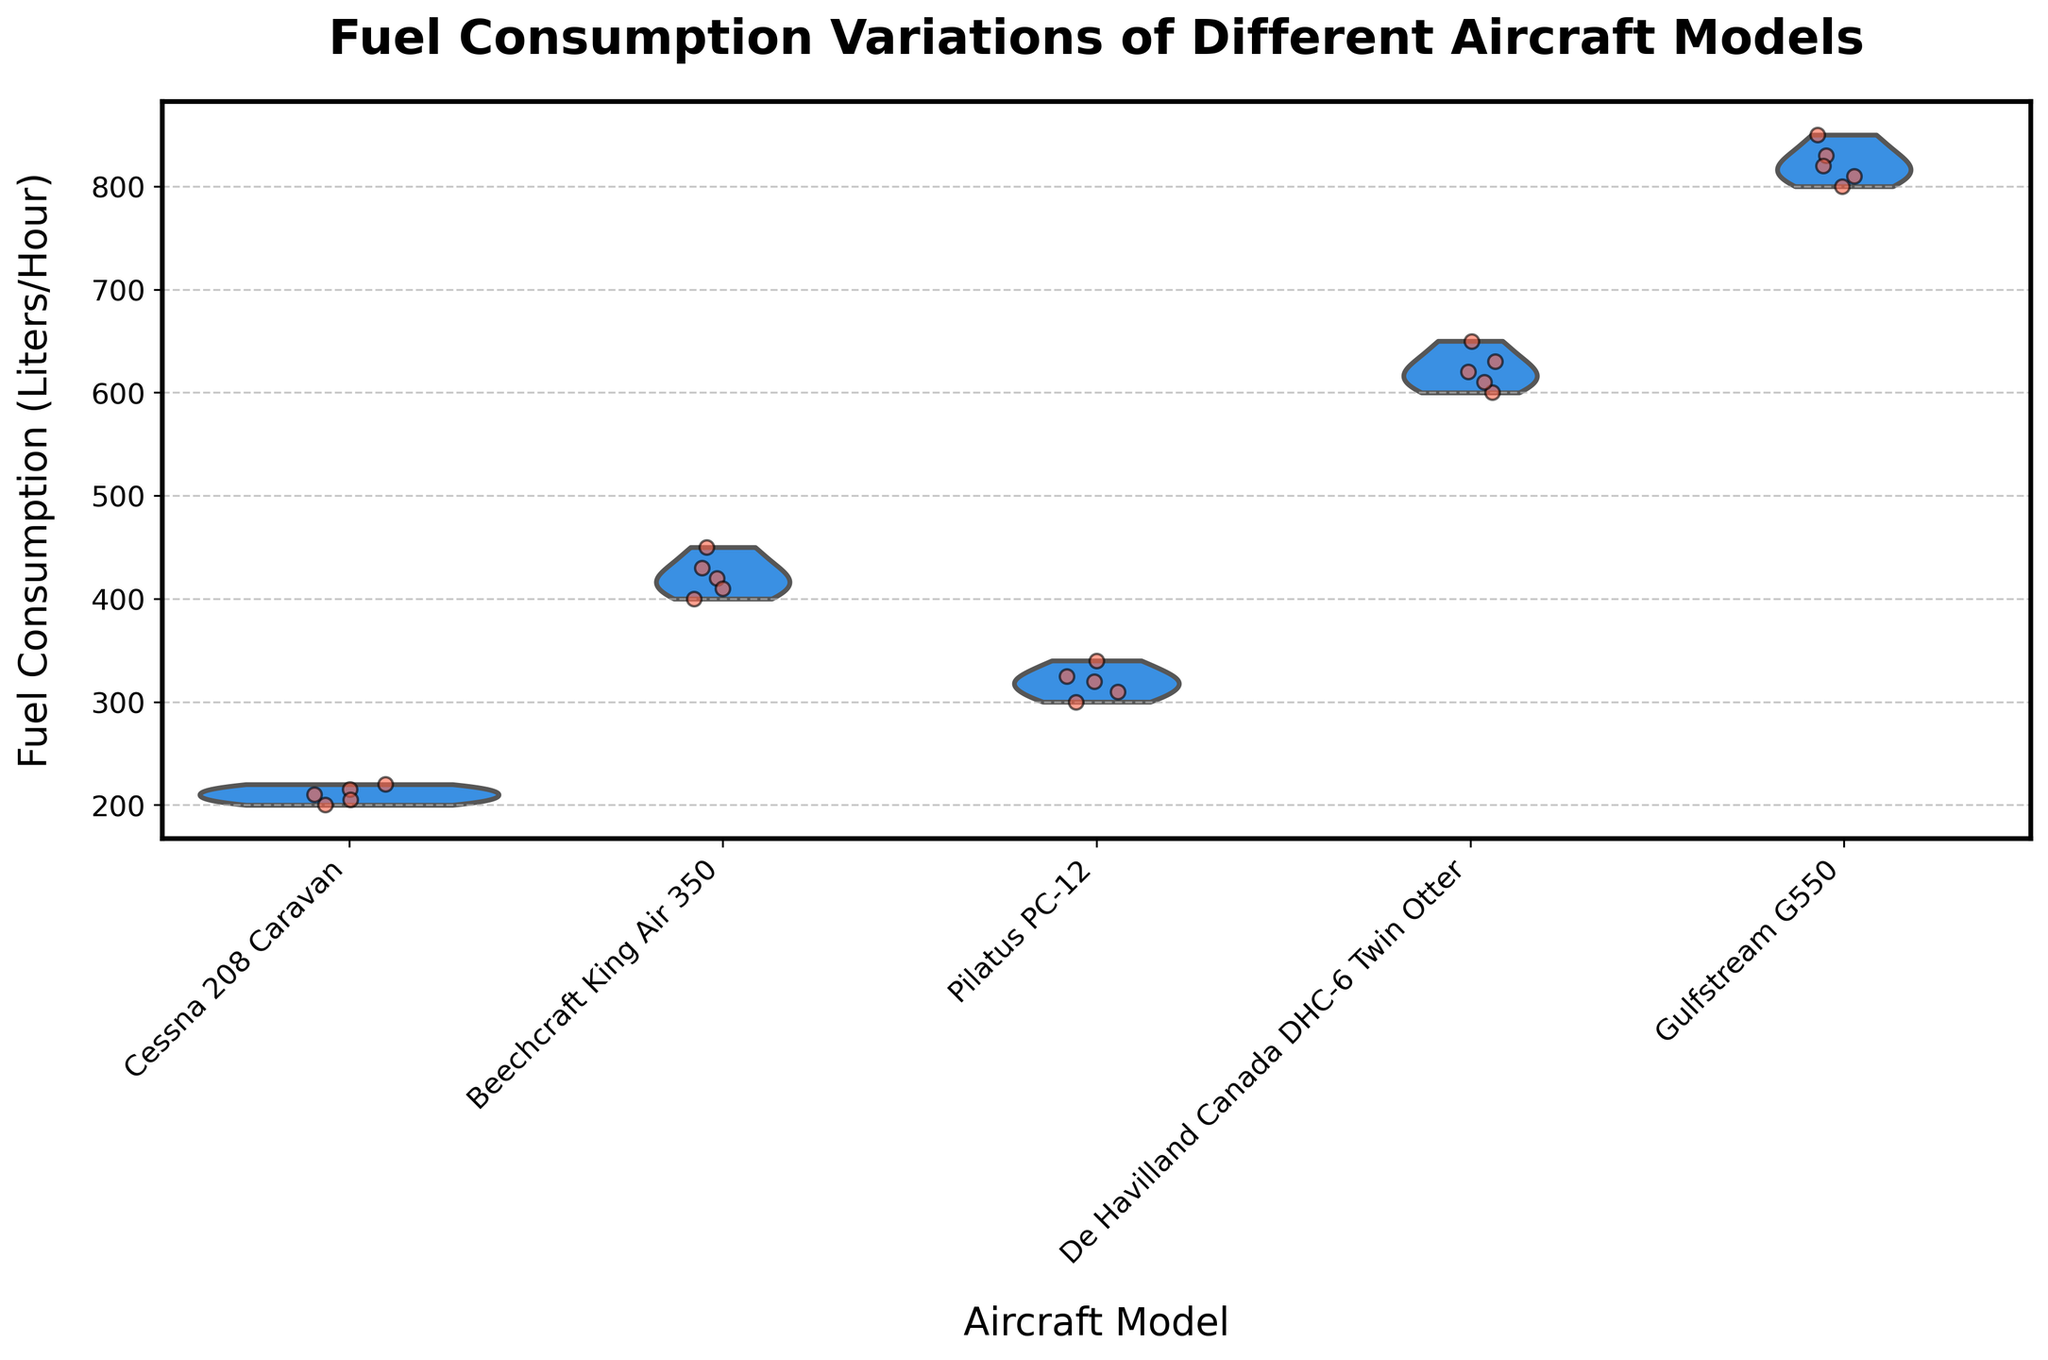What is the title of the plot? The title can be found at the top of the plot, where it is usually prominently displayed. The title reads "Fuel Consumption Variations of Different Aircraft Models."
Answer: Fuel Consumption Variations of Different Aircraft Models Which aircraft model has the highest median fuel consumption? By observing the violin plots, the aircraft model with the highest median line (usually white dot or line) needs to be identified. The Gulfstream G550 shows the highest median fuel consumption.
Answer: Gulfstream G550 What is the range of fuel consumption for the Pilatus PC-12? The range can be assessed by looking at the extent of the violin plot from the lowest to the highest points. For the Pilatus PC-12, this range goes from about 300 to 340 liters per hour.
Answer: 300-340 liters per hour Which aircraft model shows the widest range of fuel consumption? To find this, we look at the violin plot with the largest vertical span from the minimum to maximum values. The De Havilland Canada DHC-6 Twin Otter has the widest range.
Answer: De Havilland Canada DHC-6 Twin Otter Compare the fuel consumption variations between the Cessna 208 Caravan and Beechcraft King Air 350. Which has a greater spread? This requires examining both violin plots to see the distribution's range. The Beechcraft King Air 350 has a larger spread as the violin plot is more elongated vertically.
Answer: Beechcraft King Air 350 How many data points are there for the Gulfstream G550? By counting the jittered points (individual dots), we see that there are 5 data points for the Gulfstream G550.
Answer: 5 Are there any aircraft models with overlapping fuel consumption ranges? If yes, which ones? To answer this, we need to see if the violin plots overlap vertically. The Cessna 208 Caravan and Pilatus PC-12 have overlapping ranges from around 200 to 220 liters per hour.
Answer: Cessna 208 Caravan and Pilatus PC-12 Which group shows the smallest variation in fuel consumption? The smallest variation corresponds to the narrowest and shortest violin plot. The Cessna 208 Caravan shows the smallest variation since its plot is quite compact.
Answer: Cessna 208 Caravan What is the approximate median fuel consumption for the De Havilland Canada DHC-6 Twin Otter? The median is identifiable by the central value of the widest part of the violin plot. For the De Havilland Canada DHC-6 Twin Otter, this is around 630 liters per hour.
Answer: 630 liters per hour What is the common characteristic among all the aircraft models' fuel consumptions as shown in the violin plots? Each violin plot shows the distribution of fuel consumption values and includes a median line. They all indicate variance in fuel consumption rates across different distances.
Answer: Variance in fuel consumption rates 